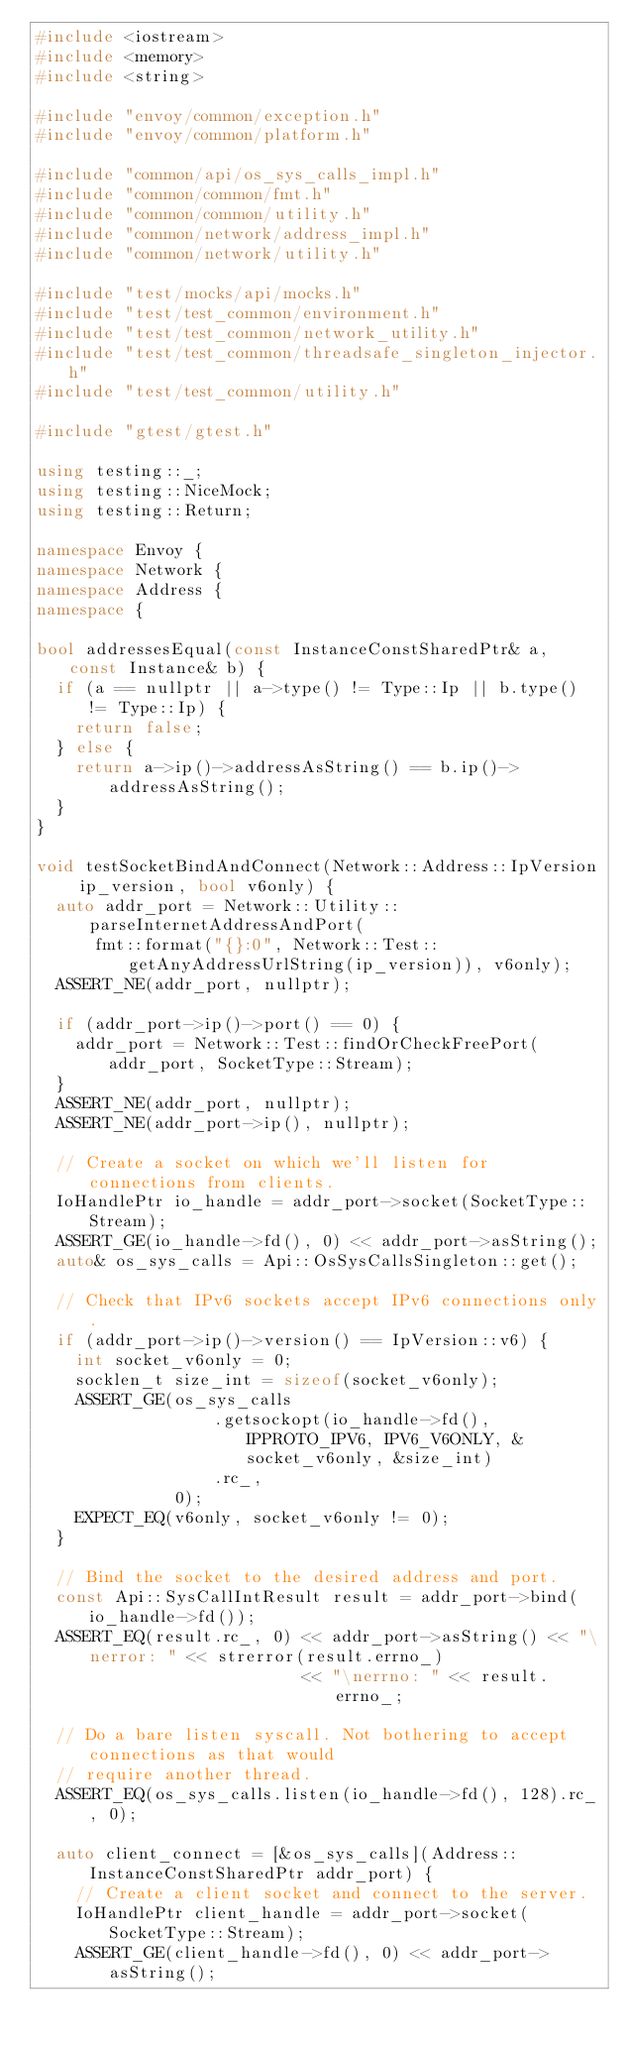Convert code to text. <code><loc_0><loc_0><loc_500><loc_500><_C++_>#include <iostream>
#include <memory>
#include <string>

#include "envoy/common/exception.h"
#include "envoy/common/platform.h"

#include "common/api/os_sys_calls_impl.h"
#include "common/common/fmt.h"
#include "common/common/utility.h"
#include "common/network/address_impl.h"
#include "common/network/utility.h"

#include "test/mocks/api/mocks.h"
#include "test/test_common/environment.h"
#include "test/test_common/network_utility.h"
#include "test/test_common/threadsafe_singleton_injector.h"
#include "test/test_common/utility.h"

#include "gtest/gtest.h"

using testing::_;
using testing::NiceMock;
using testing::Return;

namespace Envoy {
namespace Network {
namespace Address {
namespace {

bool addressesEqual(const InstanceConstSharedPtr& a, const Instance& b) {
  if (a == nullptr || a->type() != Type::Ip || b.type() != Type::Ip) {
    return false;
  } else {
    return a->ip()->addressAsString() == b.ip()->addressAsString();
  }
}

void testSocketBindAndConnect(Network::Address::IpVersion ip_version, bool v6only) {
  auto addr_port = Network::Utility::parseInternetAddressAndPort(
      fmt::format("{}:0", Network::Test::getAnyAddressUrlString(ip_version)), v6only);
  ASSERT_NE(addr_port, nullptr);

  if (addr_port->ip()->port() == 0) {
    addr_port = Network::Test::findOrCheckFreePort(addr_port, SocketType::Stream);
  }
  ASSERT_NE(addr_port, nullptr);
  ASSERT_NE(addr_port->ip(), nullptr);

  // Create a socket on which we'll listen for connections from clients.
  IoHandlePtr io_handle = addr_port->socket(SocketType::Stream);
  ASSERT_GE(io_handle->fd(), 0) << addr_port->asString();
  auto& os_sys_calls = Api::OsSysCallsSingleton::get();

  // Check that IPv6 sockets accept IPv6 connections only.
  if (addr_port->ip()->version() == IpVersion::v6) {
    int socket_v6only = 0;
    socklen_t size_int = sizeof(socket_v6only);
    ASSERT_GE(os_sys_calls
                  .getsockopt(io_handle->fd(), IPPROTO_IPV6, IPV6_V6ONLY, &socket_v6only, &size_int)
                  .rc_,
              0);
    EXPECT_EQ(v6only, socket_v6only != 0);
  }

  // Bind the socket to the desired address and port.
  const Api::SysCallIntResult result = addr_port->bind(io_handle->fd());
  ASSERT_EQ(result.rc_, 0) << addr_port->asString() << "\nerror: " << strerror(result.errno_)
                           << "\nerrno: " << result.errno_;

  // Do a bare listen syscall. Not bothering to accept connections as that would
  // require another thread.
  ASSERT_EQ(os_sys_calls.listen(io_handle->fd(), 128).rc_, 0);

  auto client_connect = [&os_sys_calls](Address::InstanceConstSharedPtr addr_port) {
    // Create a client socket and connect to the server.
    IoHandlePtr client_handle = addr_port->socket(SocketType::Stream);
    ASSERT_GE(client_handle->fd(), 0) << addr_port->asString();
</code> 